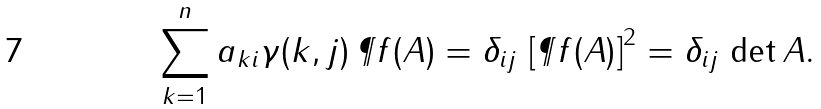Convert formula to latex. <formula><loc_0><loc_0><loc_500><loc_500>\sum _ { k = 1 } ^ { n } a _ { k i } \gamma ( k , j ) \, \P f ( A ) = \delta _ { i j } \, \left [ \P f ( A ) \right ] ^ { 2 } = \delta _ { i j } \, \det A .</formula> 